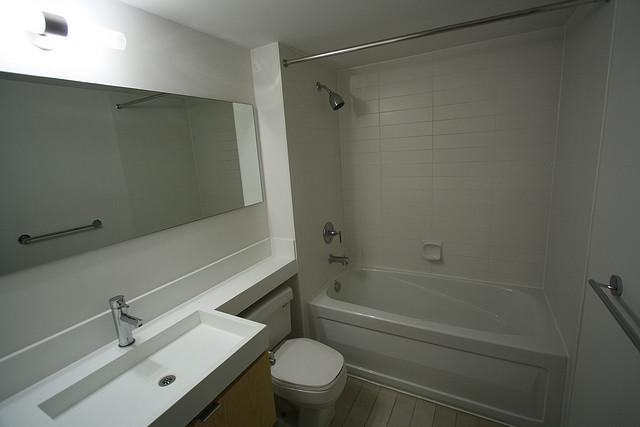What room is the picture taken from?
Keep it brief. Bathroom. How many sinks are there?
Write a very short answer. 1. Does this tub have a curtain?
Short answer required. No. What is the reflective object above the sink called?
Short answer required. Mirror. Where would a person hand their towels?
Be succinct. Towel bar. Could a thrown rock shatter the shower glass?
Be succinct. No. 